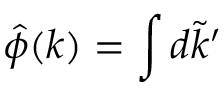<formula> <loc_0><loc_0><loc_500><loc_500>\hat { \phi } ( k ) = \int d \tilde { k } ^ { \prime }</formula> 